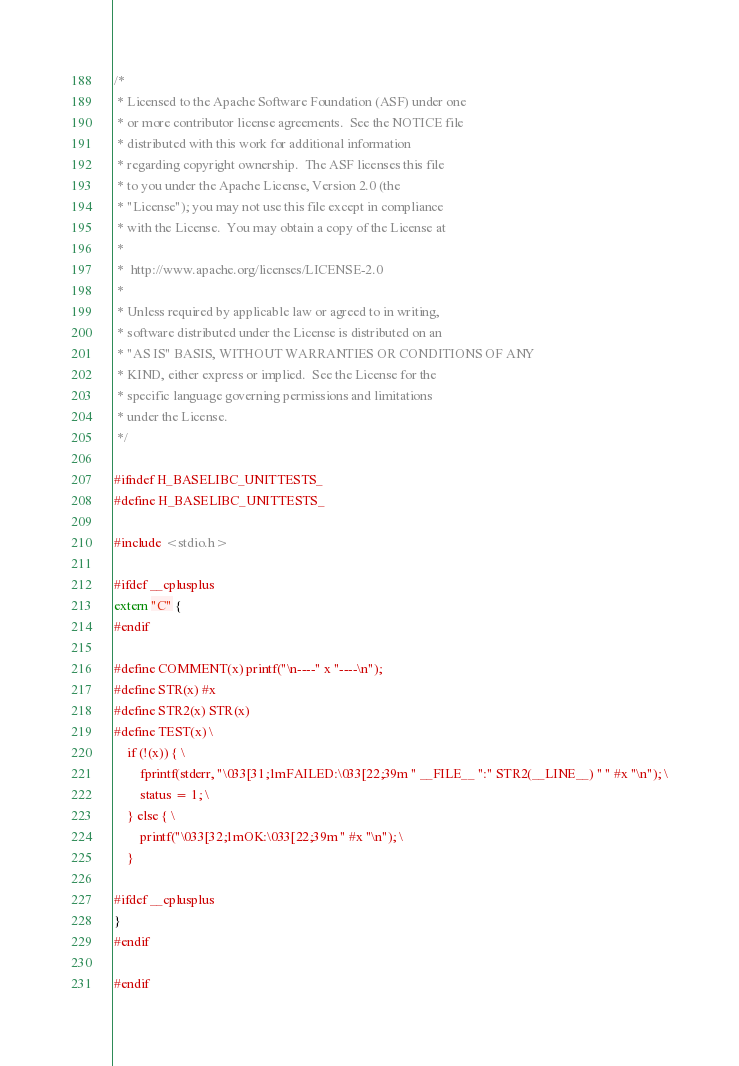<code> <loc_0><loc_0><loc_500><loc_500><_C_>/*
 * Licensed to the Apache Software Foundation (ASF) under one
 * or more contributor license agreements.  See the NOTICE file
 * distributed with this work for additional information
 * regarding copyright ownership.  The ASF licenses this file
 * to you under the Apache License, Version 2.0 (the
 * "License"); you may not use this file except in compliance
 * with the License.  You may obtain a copy of the License at
 *
 *  http://www.apache.org/licenses/LICENSE-2.0
 *
 * Unless required by applicable law or agreed to in writing,
 * software distributed under the License is distributed on an
 * "AS IS" BASIS, WITHOUT WARRANTIES OR CONDITIONS OF ANY
 * KIND, either express or implied.  See the License for the
 * specific language governing permissions and limitations
 * under the License.
 */

#ifndef H_BASELIBC_UNITTESTS_
#define H_BASELIBC_UNITTESTS_

#include <stdio.h>

#ifdef __cplusplus
extern "C" {
#endif

#define COMMENT(x) printf("\n----" x "----\n");
#define STR(x) #x
#define STR2(x) STR(x)
#define TEST(x) \
    if (!(x)) { \
        fprintf(stderr, "\033[31;1mFAILED:\033[22;39m " __FILE__ ":" STR2(__LINE__) " " #x "\n"); \
        status = 1; \
    } else { \
        printf("\033[32;1mOK:\033[22;39m " #x "\n"); \
    }

#ifdef __cplusplus
}
#endif

#endif
</code> 